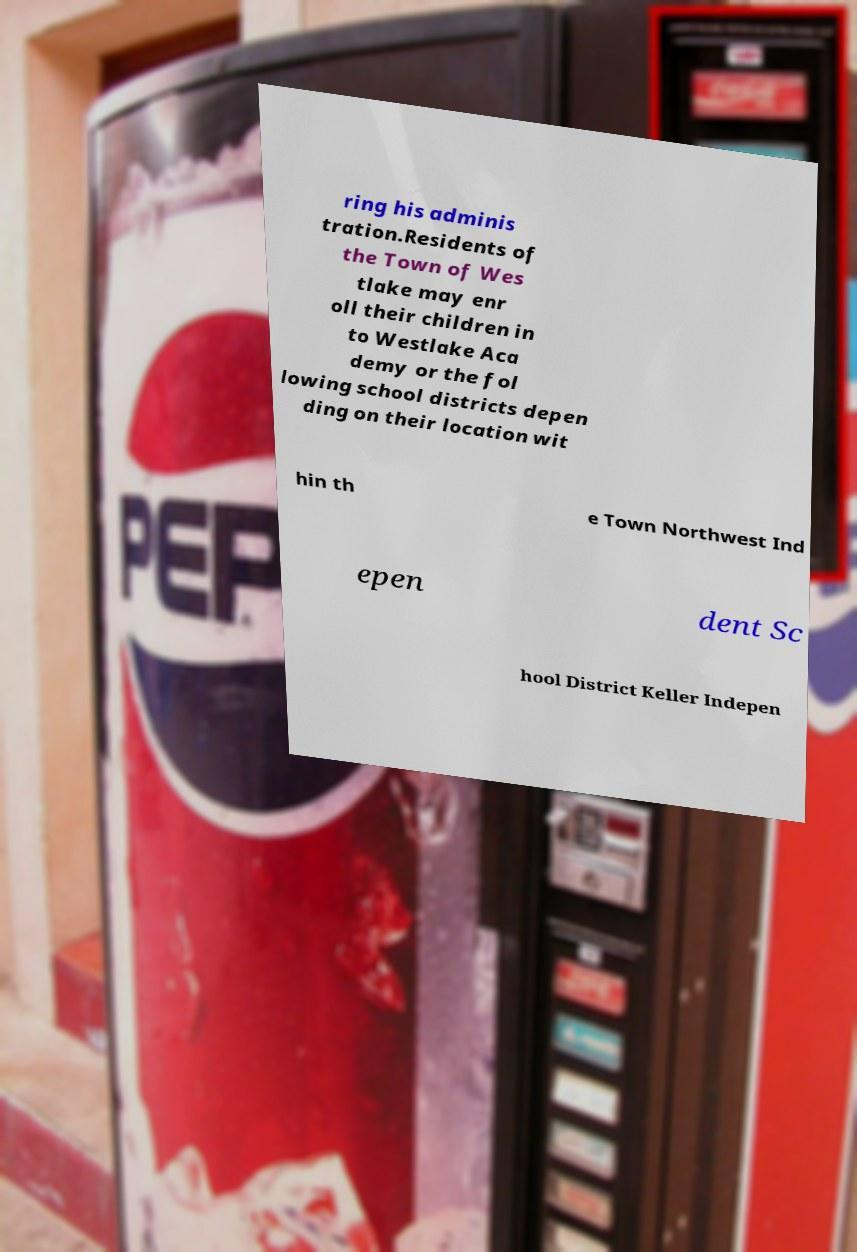There's text embedded in this image that I need extracted. Can you transcribe it verbatim? ring his adminis tration.Residents of the Town of Wes tlake may enr oll their children in to Westlake Aca demy or the fol lowing school districts depen ding on their location wit hin th e Town Northwest Ind epen dent Sc hool District Keller Indepen 